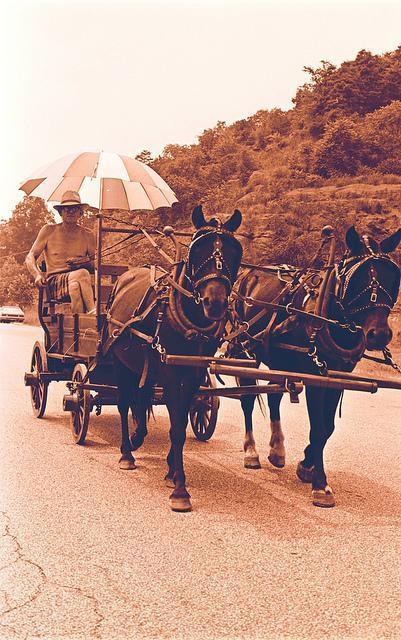How many umbrellas are there?
Give a very brief answer. 1. How many horses are there?
Give a very brief answer. 2. How many horses can you see?
Give a very brief answer. 2. How many elephants are there?
Give a very brief answer. 0. 